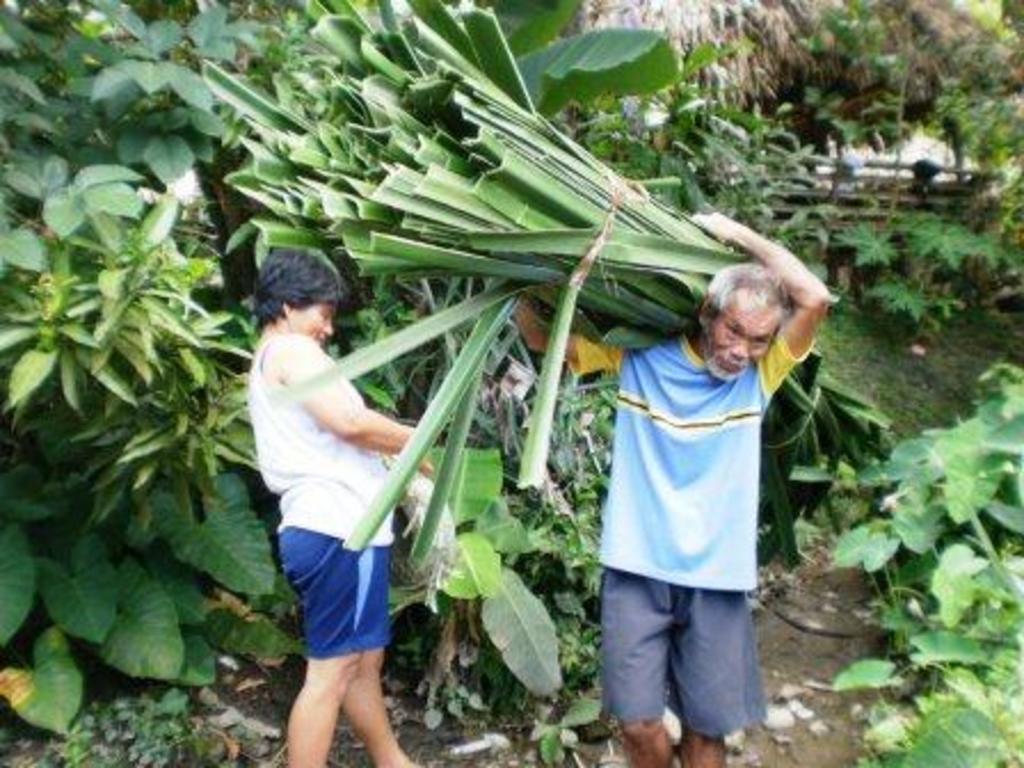In one or two sentences, can you explain what this image depicts? In this image we can see two persons. There are many trees and plants in the image. A man is carrying leaves of the plant on his shoulder. 